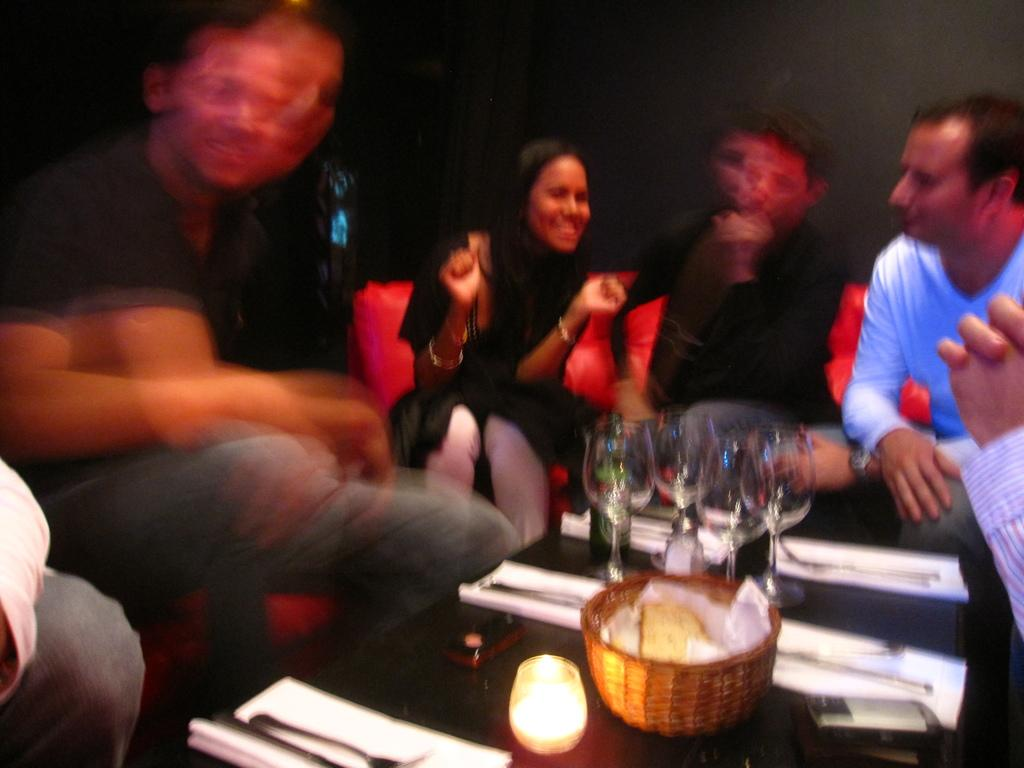What are the people in the image doing? The people are sitting on a couch. What other furniture or objects can be seen in the image? There is a table in the image. What is on the table? There is a basket, plates, spoons, and wine glasses on the table. How does the image appear? The image appears to be blurry. Can you describe the pies that are being served during the rainstorm on the sidewalk in the image? There are no pies, rainstorm, or sidewalk present in the image. 